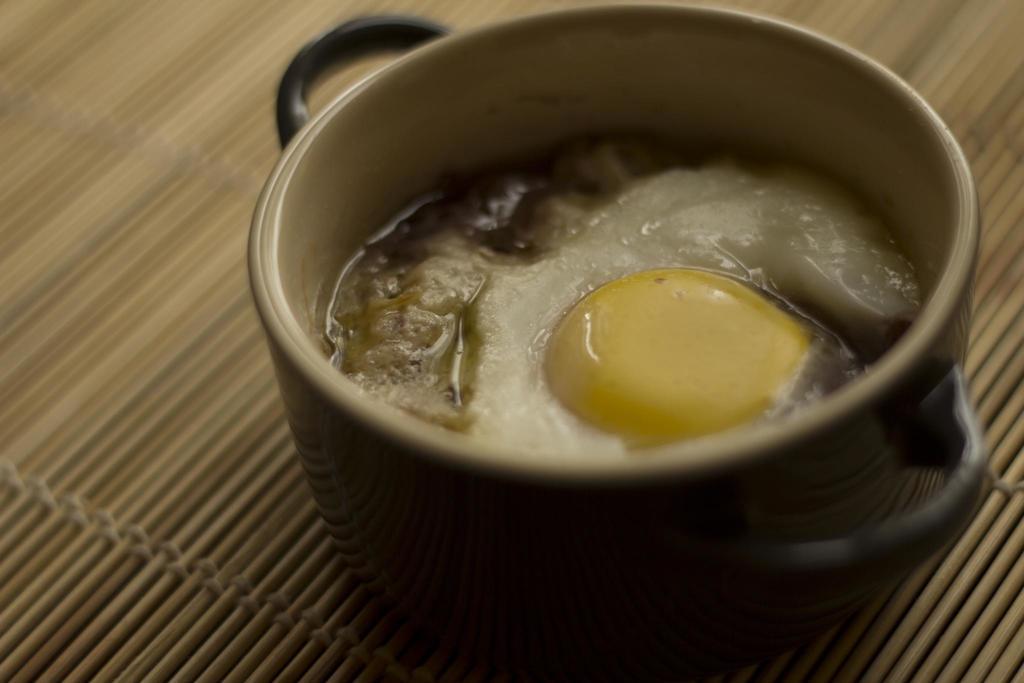How would you summarize this image in a sentence or two? In this picture we can see food in a bowl and the bowl is on an object. 